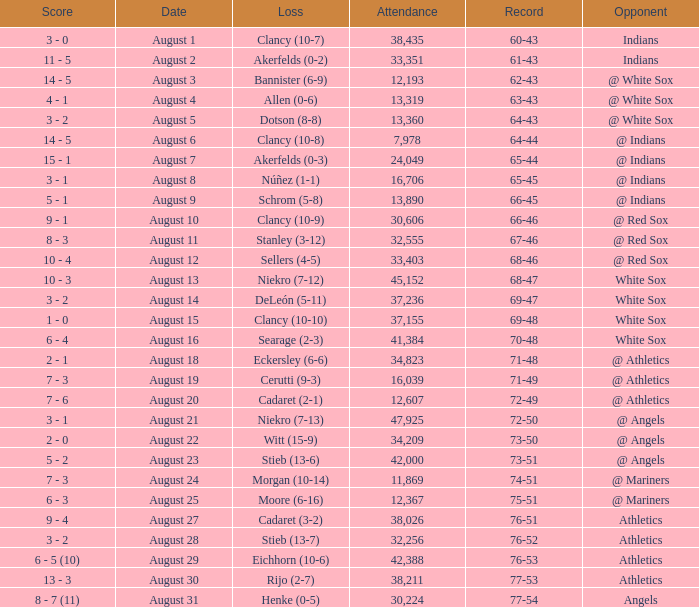What was the attendance when the record was 77-54? 30224.0. 